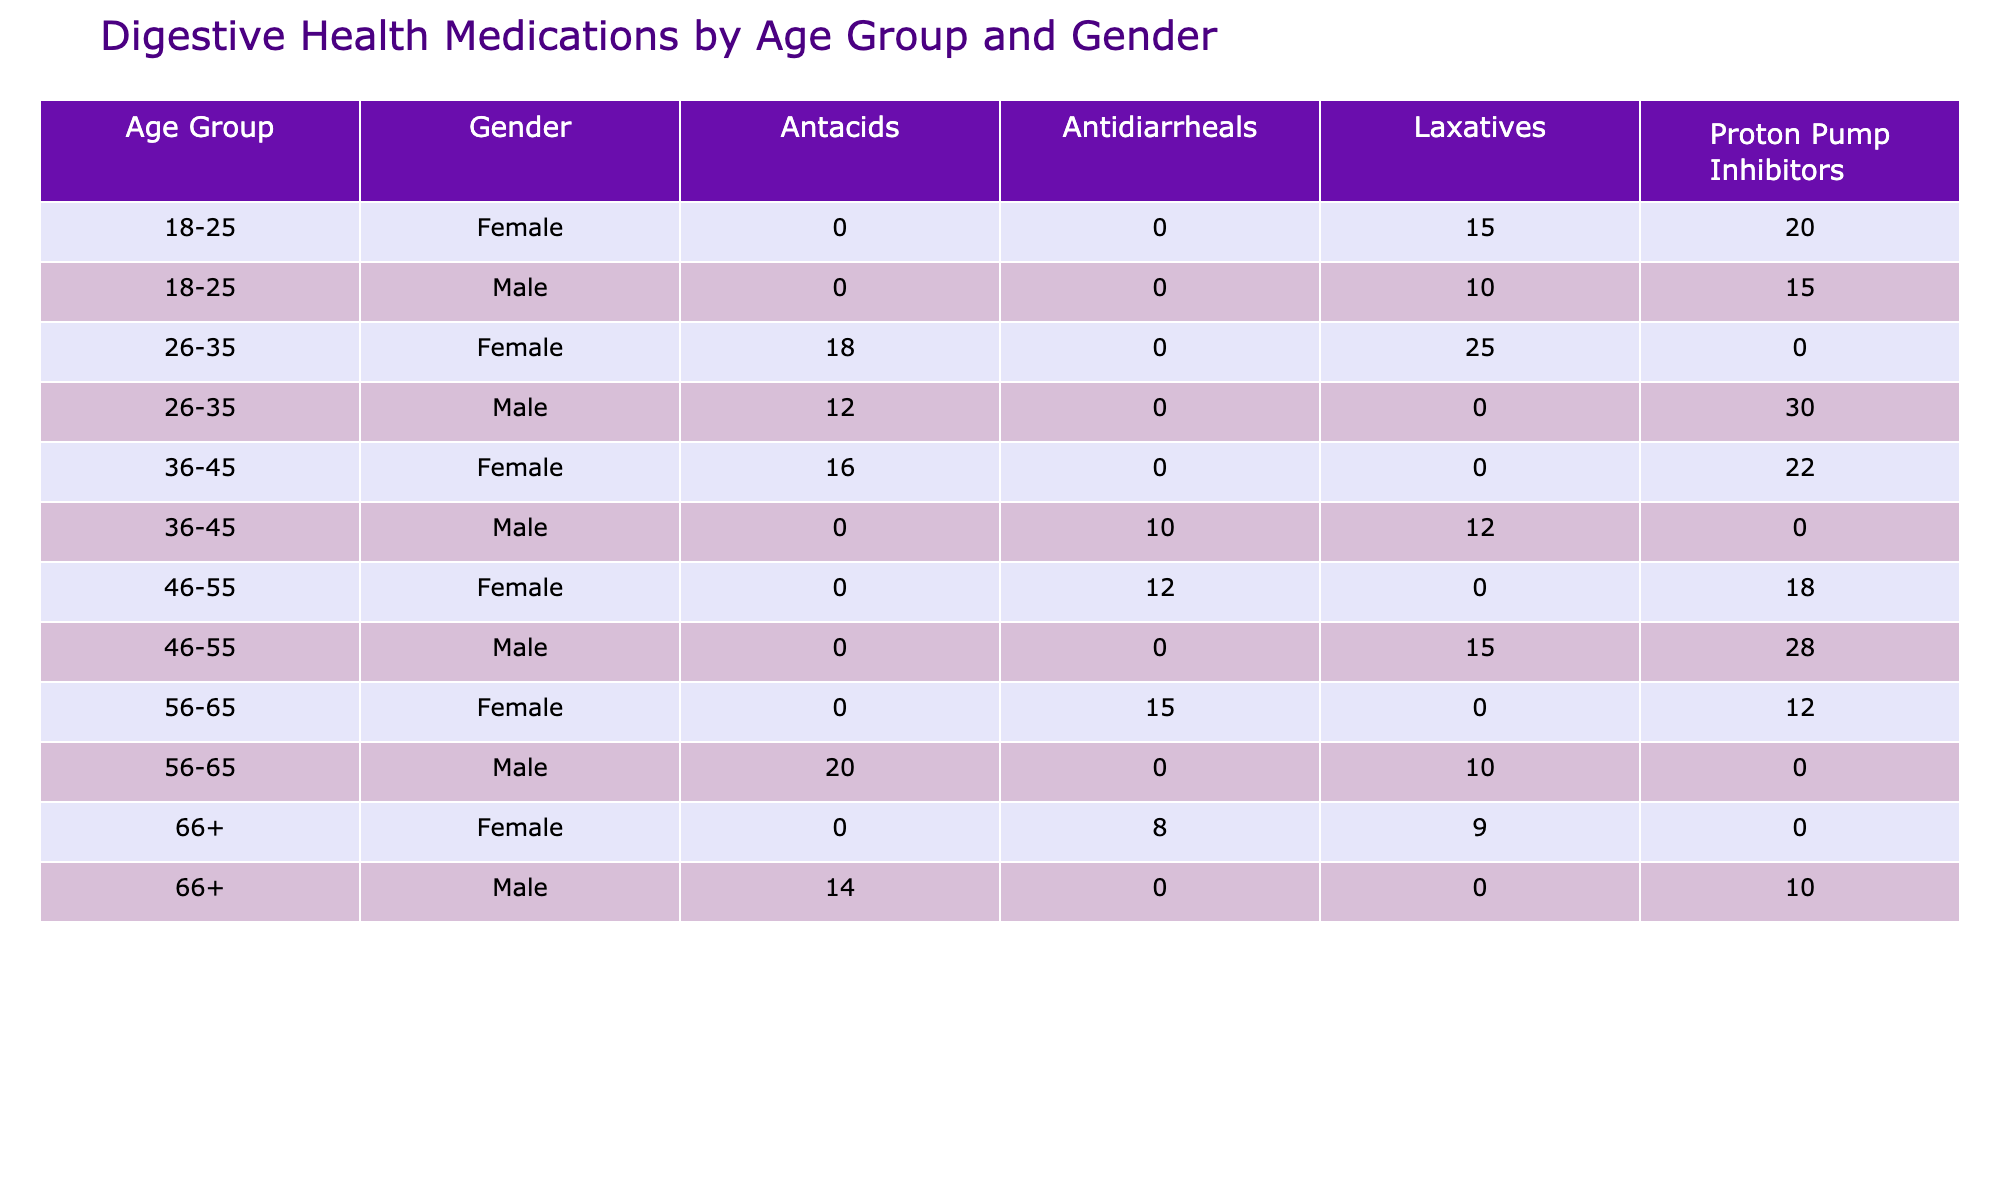What medication type is prescribed most frequently to males aged 26-35? In the table, we look for the '26-35' age group and filter it by 'Male'. The medication types prescribed to males in this age group are Antacids (12), Proton Pump Inhibitors (30), and Laxatives (25). The highest count is for Proton Pump Inhibitors at 30.
Answer: Proton Pump Inhibitors Is the total number of Proton Pump Inhibitors prescribed to females across all age groups greater than those prescribed to males? First, we add up the counts of Proton Pump Inhibitors for females: 20 (18-25) + 22 (36-45) + 18 (46-55) + 12 (56-65) = 72. For males, we sum the counts: 15 (18-25) + 30 (26-35) + 10 (66+) = 55. Since 72 is greater than 55, the statement is true.
Answer: Yes How many more Laxatives were prescribed to females than to males in the age group 36-45? For the age group 36-45, we look at Laxatives. Females were prescribed 12, while males were prescribed 10. The difference is calculated as 12 - 10 = 2.
Answer: 2 What is the total number of Antidiarrheals prescribed across all age groups for both genders? We find the counts of Antidiarrheals across age groups. For males: 10 (36-45) and for females: 12 (46-55) + 15 (56-65) + 8 (66+) = 35. Therefore, combining male and female counts gives us 10 + 35 = 45.
Answer: 45 Which age group has the highest number of Antacids prescribed overall, and what is that total? We examine the Antacids prescribed by age group. The counts are 12 (26-35, Male) + 18 (26-35, Female) = 30, 16 (36-45, Female) + 20 (56-65, Male) = 36, and 14 (66+, Male). The highest total is for the 36-45 age group at 36.
Answer: 36, Age group 36-45 What fraction of males aged 66 and above were prescribed Proton Pump Inhibitors? The total number of males aged 66+ for medication is 10 (Proton Pump Inhibitors) + 14 (Antacids) = 24. The Proton Pump Inhibitors to total ratio is 10/24 = 5/12 or approximately 0.42, or 42%.
Answer: Approximately 42% 